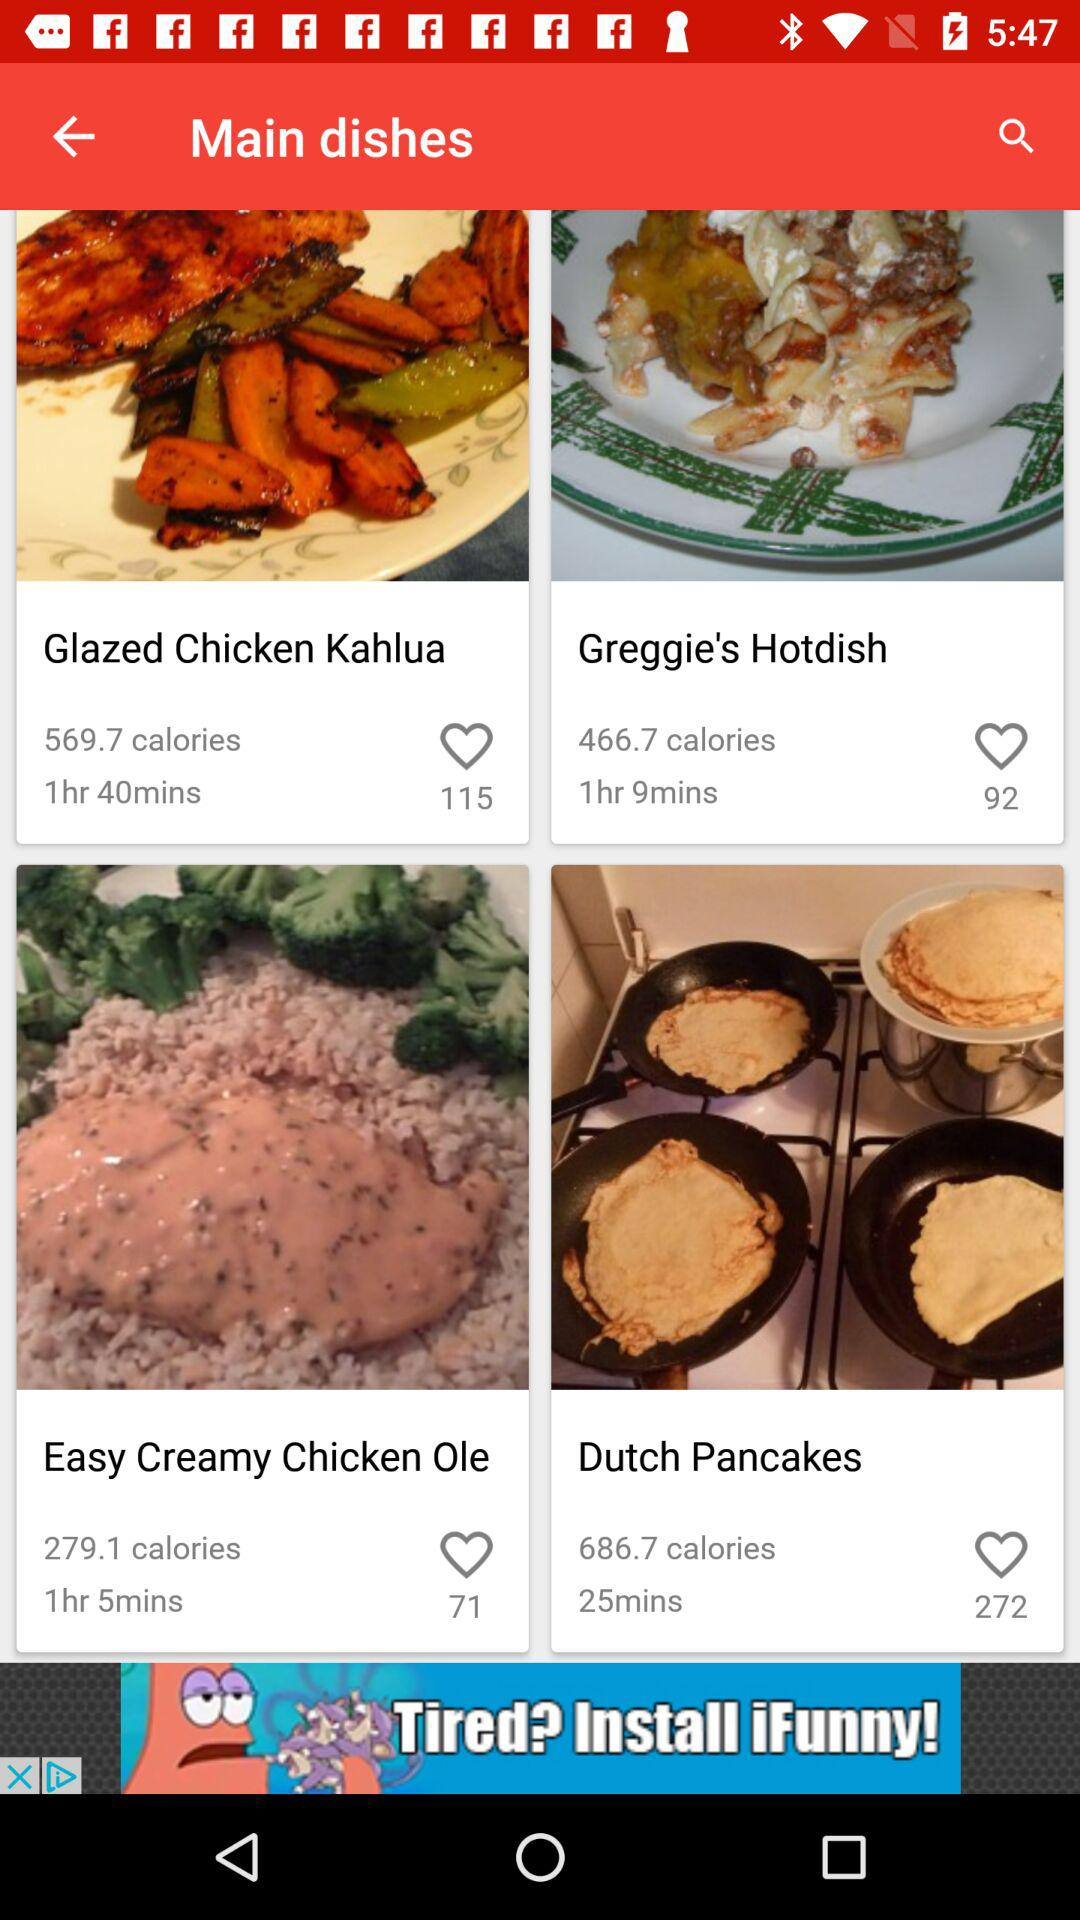How many calories are there in "Dutch Pancakes"? There are 686.7 calories in "Dutch Pancakes". 